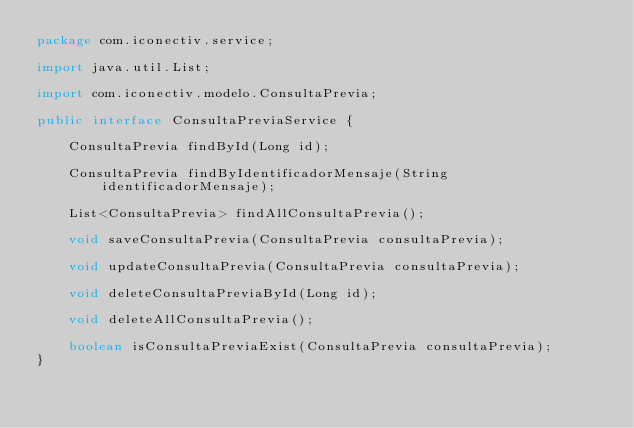Convert code to text. <code><loc_0><loc_0><loc_500><loc_500><_Java_>package com.iconectiv.service;

import java.util.List;

import com.iconectiv.modelo.ConsultaPrevia;

public interface ConsultaPreviaService {
	
	ConsultaPrevia findById(Long id);
	
	ConsultaPrevia findByIdentificadorMensaje(String identificadorMensaje);
	
	List<ConsultaPrevia> findAllConsultaPrevia();
	
	void saveConsultaPrevia(ConsultaPrevia consultaPrevia);
	
	void updateConsultaPrevia(ConsultaPrevia consultaPrevia);
	
	void deleteConsultaPreviaById(Long id);
	
	void deleteAllConsultaPrevia();
	
	boolean isConsultaPreviaExist(ConsultaPrevia consultaPrevia);
}
</code> 